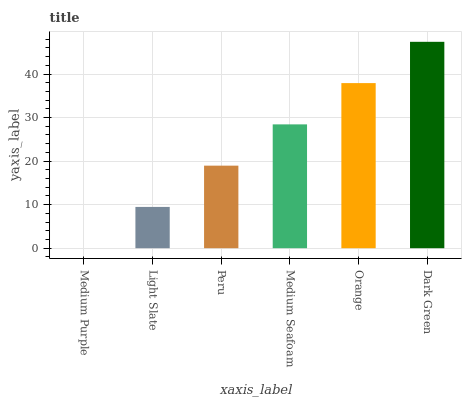Is Medium Purple the minimum?
Answer yes or no. Yes. Is Dark Green the maximum?
Answer yes or no. Yes. Is Light Slate the minimum?
Answer yes or no. No. Is Light Slate the maximum?
Answer yes or no. No. Is Light Slate greater than Medium Purple?
Answer yes or no. Yes. Is Medium Purple less than Light Slate?
Answer yes or no. Yes. Is Medium Purple greater than Light Slate?
Answer yes or no. No. Is Light Slate less than Medium Purple?
Answer yes or no. No. Is Medium Seafoam the high median?
Answer yes or no. Yes. Is Peru the low median?
Answer yes or no. Yes. Is Dark Green the high median?
Answer yes or no. No. Is Medium Seafoam the low median?
Answer yes or no. No. 